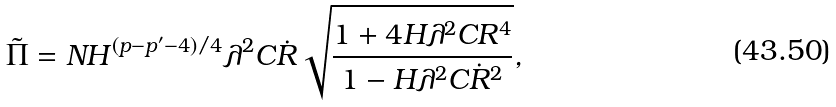Convert formula to latex. <formula><loc_0><loc_0><loc_500><loc_500>\tilde { \Pi } = N H ^ { ( p - p ^ { \prime } - 4 ) / 4 } \lambda ^ { 2 } C \dot { R } \sqrt { \frac { 1 + 4 H \lambda ^ { 2 } C R ^ { 4 } } { 1 - H \lambda ^ { 2 } C \dot { R } ^ { 2 } } } ,</formula> 